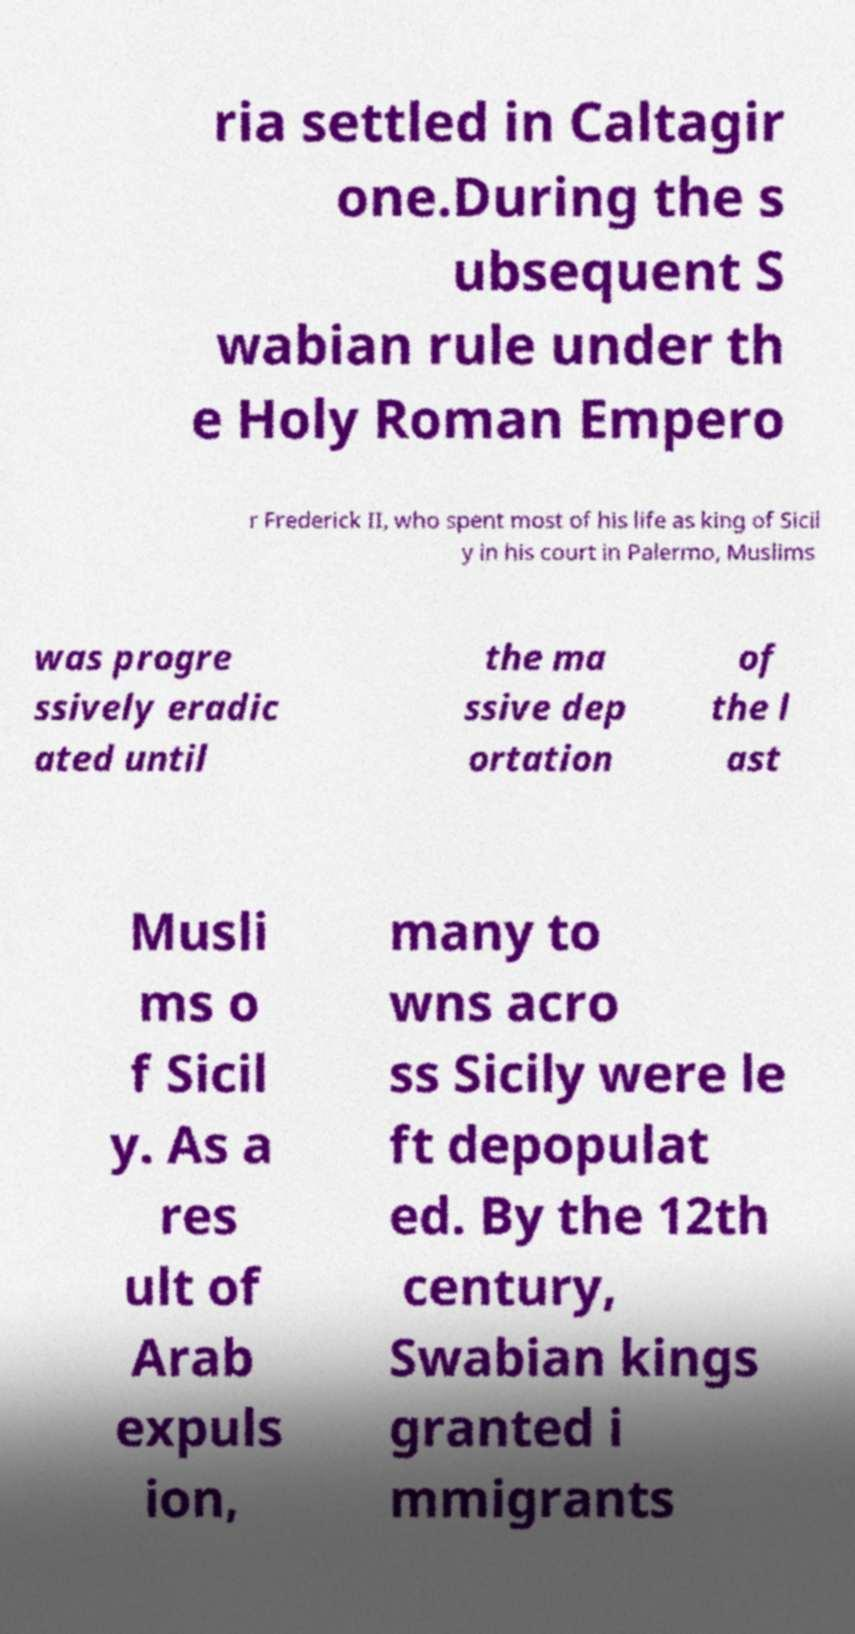Could you assist in decoding the text presented in this image and type it out clearly? ria settled in Caltagir one.During the s ubsequent S wabian rule under th e Holy Roman Empero r Frederick II, who spent most of his life as king of Sicil y in his court in Palermo, Muslims was progre ssively eradic ated until the ma ssive dep ortation of the l ast Musli ms o f Sicil y. As a res ult of Arab expuls ion, many to wns acro ss Sicily were le ft depopulat ed. By the 12th century, Swabian kings granted i mmigrants 